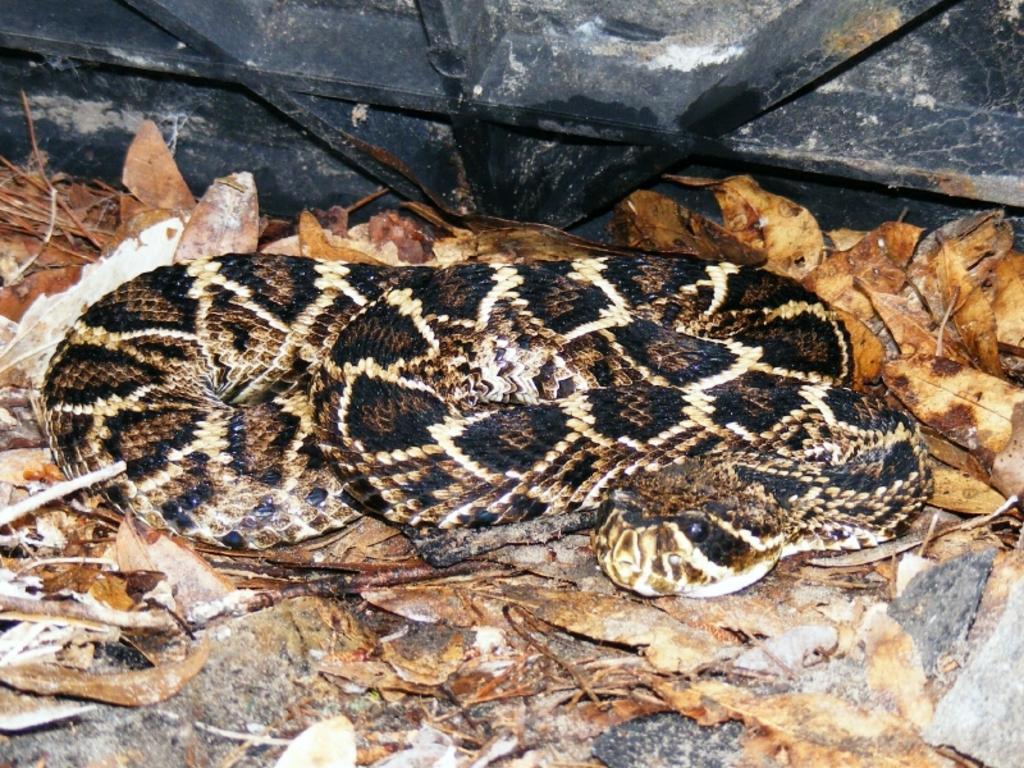Describe this image in one or two sentences. In the foreground of this image, there is a snake and few dry leaves. At the top, there is a black object. 